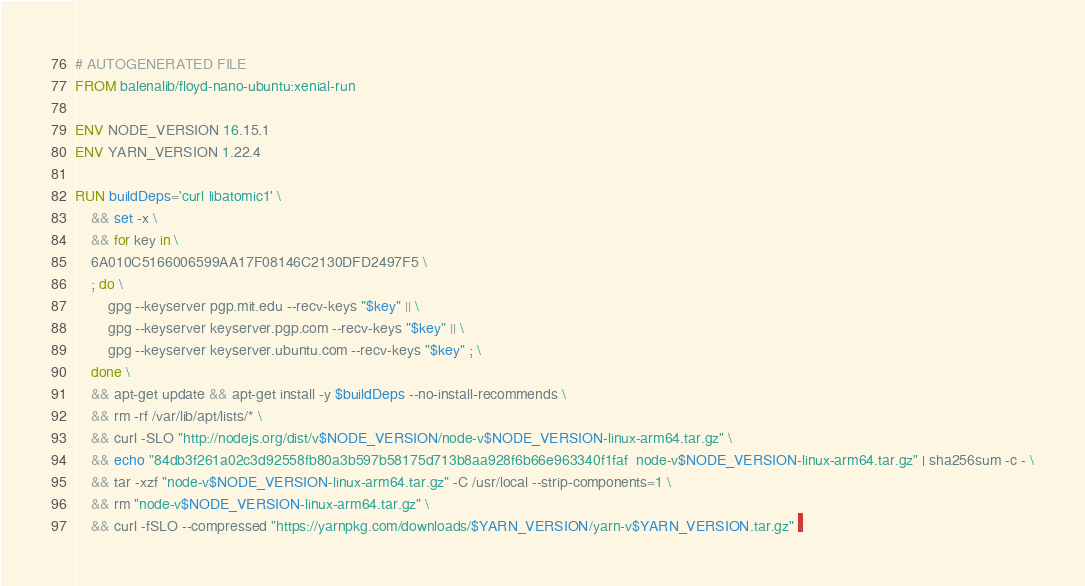<code> <loc_0><loc_0><loc_500><loc_500><_Dockerfile_># AUTOGENERATED FILE
FROM balenalib/floyd-nano-ubuntu:xenial-run

ENV NODE_VERSION 16.15.1
ENV YARN_VERSION 1.22.4

RUN buildDeps='curl libatomic1' \
	&& set -x \
	&& for key in \
	6A010C5166006599AA17F08146C2130DFD2497F5 \
	; do \
		gpg --keyserver pgp.mit.edu --recv-keys "$key" || \
		gpg --keyserver keyserver.pgp.com --recv-keys "$key" || \
		gpg --keyserver keyserver.ubuntu.com --recv-keys "$key" ; \
	done \
	&& apt-get update && apt-get install -y $buildDeps --no-install-recommends \
	&& rm -rf /var/lib/apt/lists/* \
	&& curl -SLO "http://nodejs.org/dist/v$NODE_VERSION/node-v$NODE_VERSION-linux-arm64.tar.gz" \
	&& echo "84db3f261a02c3d92558fb80a3b597b58175d713b8aa928f6b66e963340f1faf  node-v$NODE_VERSION-linux-arm64.tar.gz" | sha256sum -c - \
	&& tar -xzf "node-v$NODE_VERSION-linux-arm64.tar.gz" -C /usr/local --strip-components=1 \
	&& rm "node-v$NODE_VERSION-linux-arm64.tar.gz" \
	&& curl -fSLO --compressed "https://yarnpkg.com/downloads/$YARN_VERSION/yarn-v$YARN_VERSION.tar.gz" \</code> 